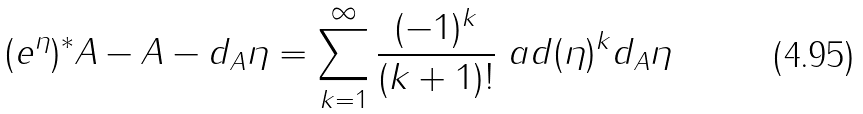Convert formula to latex. <formula><loc_0><loc_0><loc_500><loc_500>( e ^ { \eta } ) ^ { * } A - A - d _ { A } \eta = \sum _ { k = 1 } ^ { \infty } \frac { ( - 1 ) ^ { k } } { ( k + 1 ) ! } \ a d ( \eta ) ^ { k } d _ { A } \eta</formula> 